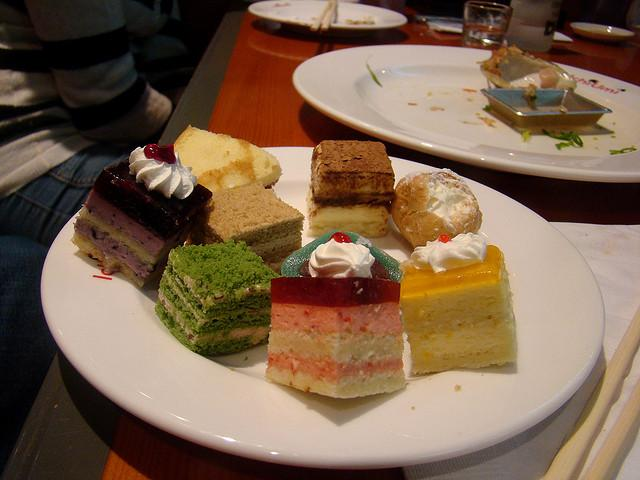What is the English translation of the French name for these?

Choices:
A) little cakes
B) little oven
C) small squares
D) mini bites little oven 